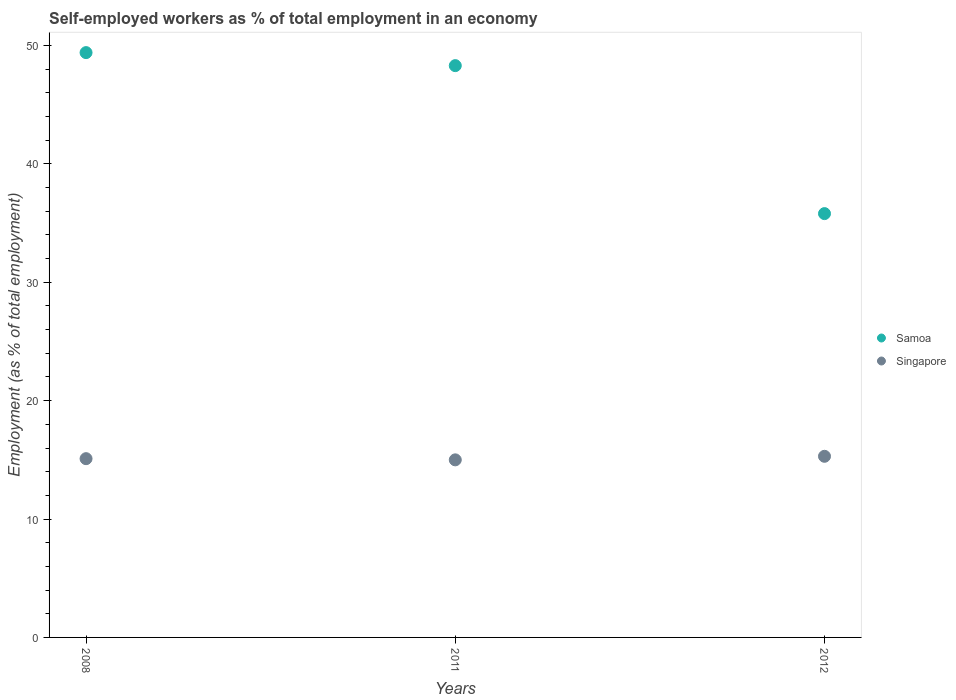What is the percentage of self-employed workers in Samoa in 2011?
Make the answer very short. 48.3. Across all years, what is the maximum percentage of self-employed workers in Samoa?
Your answer should be very brief. 49.4. Across all years, what is the minimum percentage of self-employed workers in Samoa?
Provide a short and direct response. 35.8. In which year was the percentage of self-employed workers in Samoa minimum?
Keep it short and to the point. 2012. What is the total percentage of self-employed workers in Singapore in the graph?
Keep it short and to the point. 45.4. What is the difference between the percentage of self-employed workers in Samoa in 2008 and that in 2012?
Your answer should be compact. 13.6. What is the difference between the percentage of self-employed workers in Singapore in 2011 and the percentage of self-employed workers in Samoa in 2008?
Provide a succinct answer. -34.4. What is the average percentage of self-employed workers in Samoa per year?
Your response must be concise. 44.5. In the year 2012, what is the difference between the percentage of self-employed workers in Samoa and percentage of self-employed workers in Singapore?
Offer a very short reply. 20.5. What is the ratio of the percentage of self-employed workers in Samoa in 2011 to that in 2012?
Your response must be concise. 1.35. What is the difference between the highest and the second highest percentage of self-employed workers in Samoa?
Your answer should be very brief. 1.1. What is the difference between the highest and the lowest percentage of self-employed workers in Singapore?
Provide a short and direct response. 0.3. In how many years, is the percentage of self-employed workers in Singapore greater than the average percentage of self-employed workers in Singapore taken over all years?
Your answer should be very brief. 1. Is the percentage of self-employed workers in Singapore strictly less than the percentage of self-employed workers in Samoa over the years?
Your answer should be compact. Yes. How many years are there in the graph?
Your response must be concise. 3. What is the difference between two consecutive major ticks on the Y-axis?
Your response must be concise. 10. Are the values on the major ticks of Y-axis written in scientific E-notation?
Offer a very short reply. No. Does the graph contain any zero values?
Make the answer very short. No. Does the graph contain grids?
Provide a succinct answer. No. How are the legend labels stacked?
Provide a short and direct response. Vertical. What is the title of the graph?
Provide a succinct answer. Self-employed workers as % of total employment in an economy. What is the label or title of the Y-axis?
Your answer should be compact. Employment (as % of total employment). What is the Employment (as % of total employment) of Samoa in 2008?
Your answer should be compact. 49.4. What is the Employment (as % of total employment) of Singapore in 2008?
Keep it short and to the point. 15.1. What is the Employment (as % of total employment) of Samoa in 2011?
Provide a succinct answer. 48.3. What is the Employment (as % of total employment) in Samoa in 2012?
Your response must be concise. 35.8. What is the Employment (as % of total employment) of Singapore in 2012?
Keep it short and to the point. 15.3. Across all years, what is the maximum Employment (as % of total employment) of Samoa?
Provide a succinct answer. 49.4. Across all years, what is the maximum Employment (as % of total employment) in Singapore?
Provide a succinct answer. 15.3. Across all years, what is the minimum Employment (as % of total employment) of Samoa?
Provide a short and direct response. 35.8. Across all years, what is the minimum Employment (as % of total employment) of Singapore?
Your answer should be very brief. 15. What is the total Employment (as % of total employment) of Samoa in the graph?
Your answer should be very brief. 133.5. What is the total Employment (as % of total employment) in Singapore in the graph?
Your answer should be very brief. 45.4. What is the difference between the Employment (as % of total employment) of Samoa in 2008 and that in 2012?
Keep it short and to the point. 13.6. What is the difference between the Employment (as % of total employment) in Singapore in 2008 and that in 2012?
Your answer should be compact. -0.2. What is the difference between the Employment (as % of total employment) of Samoa in 2008 and the Employment (as % of total employment) of Singapore in 2011?
Offer a terse response. 34.4. What is the difference between the Employment (as % of total employment) of Samoa in 2008 and the Employment (as % of total employment) of Singapore in 2012?
Provide a short and direct response. 34.1. What is the difference between the Employment (as % of total employment) of Samoa in 2011 and the Employment (as % of total employment) of Singapore in 2012?
Your response must be concise. 33. What is the average Employment (as % of total employment) of Samoa per year?
Offer a very short reply. 44.5. What is the average Employment (as % of total employment) in Singapore per year?
Provide a short and direct response. 15.13. In the year 2008, what is the difference between the Employment (as % of total employment) in Samoa and Employment (as % of total employment) in Singapore?
Offer a terse response. 34.3. In the year 2011, what is the difference between the Employment (as % of total employment) of Samoa and Employment (as % of total employment) of Singapore?
Give a very brief answer. 33.3. In the year 2012, what is the difference between the Employment (as % of total employment) in Samoa and Employment (as % of total employment) in Singapore?
Ensure brevity in your answer.  20.5. What is the ratio of the Employment (as % of total employment) in Samoa in 2008 to that in 2011?
Offer a terse response. 1.02. What is the ratio of the Employment (as % of total employment) in Samoa in 2008 to that in 2012?
Offer a very short reply. 1.38. What is the ratio of the Employment (as % of total employment) of Singapore in 2008 to that in 2012?
Make the answer very short. 0.99. What is the ratio of the Employment (as % of total employment) in Samoa in 2011 to that in 2012?
Your response must be concise. 1.35. What is the ratio of the Employment (as % of total employment) of Singapore in 2011 to that in 2012?
Ensure brevity in your answer.  0.98. What is the difference between the highest and the second highest Employment (as % of total employment) of Samoa?
Your response must be concise. 1.1. 